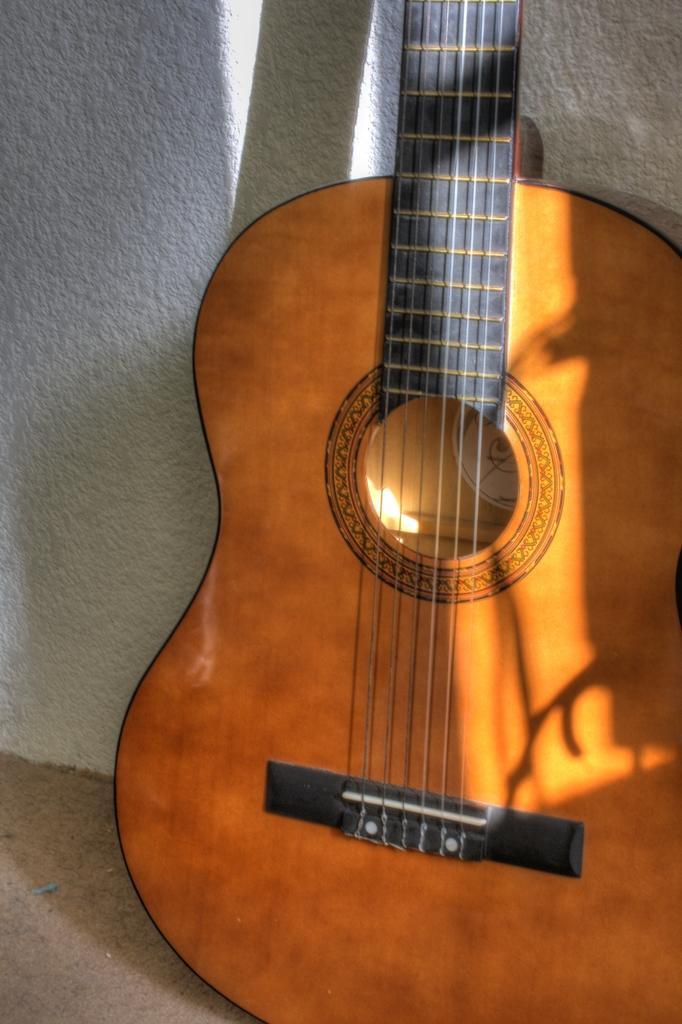Describe this image in one or two sentences. In this picture we can see a guitar with strings. On the background we can see a wall in white colour. 